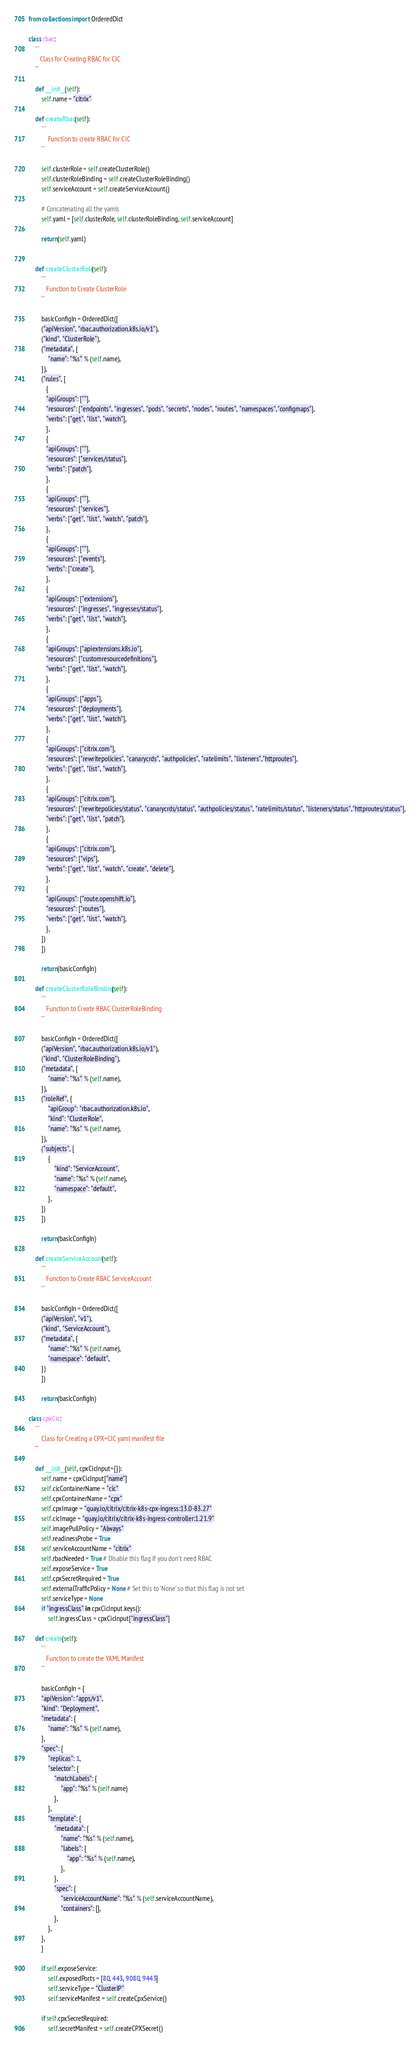Convert code to text. <code><loc_0><loc_0><loc_500><loc_500><_Python_>from collections import OrderedDict

class rbac:
    '''
       Class for Creating RBAC for CIC
    '''

    def __init__(self):
        self.name = "citrix"

    def createRbac(self):
        '''
            Function to create RBAC for CIC
        '''

        self.clusterRole = self.createClusterRole()
        self.clusterRoleBinding = self.createClusterRoleBinding()
        self.serviceAccount = self.createServiceAccount()

        # Concatenating all the yamls
        self.yaml = [self.clusterRole, self.clusterRoleBinding, self.serviceAccount]

        return(self.yaml)


    def createClusterRole(self):
        '''
           Function to Create ClusterRole
        '''

        basicConfigIn = OrderedDict([
        ("apiVersion", "rbac.authorization.k8s.io/v1"),
        ("kind", "ClusterRole"),
        ("metadata", {
            "name": "%s" % (self.name),
        }),
        ("rules", [
           {
           "apiGroups": [""],
           "resources": ["endpoints", "ingresses", "pods", "secrets", "nodes", "routes", "namespaces","configmaps"],
           "verbs": ["get", "list", "watch"],
           },
           {
           "apiGroups": [""],
           "resources": ["services/status"],
           "verbs": ["patch"],
           },
           {
           "apiGroups": [""],
           "resources": ["services"],
           "verbs": ["get", "list", "watch", "patch"],
           },
           {
           "apiGroups": [""],
           "resources": ["events"],
           "verbs": ["create"],
           },
           {
           "apiGroups": ["extensions"],
           "resources": ["ingresses", "ingresses/status"],
           "verbs": ["get", "list", "watch"],
           },
           {
           "apiGroups": ["apiextensions.k8s.io"],
           "resources": ["customresourcedefinitions"],
           "verbs": ["get", "list", "watch"],
           },
           {
           "apiGroups": ["apps"],
           "resources": ["deployments"],
           "verbs": ["get", "list", "watch"],
           },
           {
           "apiGroups": ["citrix.com"],
           "resources": ["rewritepolicies", "canarycrds", "authpolicies", "ratelimits", "listeners","httproutes"],
           "verbs": ["get", "list", "watch"],
           },
           {
           "apiGroups": ["citrix.com"],
           "resources": ["rewritepolicies/status", "canarycrds/status", "authpolicies/status", "ratelimits/status", "listeners/status","httproutes/status"],
           "verbs": ["get", "list", "patch"],
           },
           {
           "apiGroups": ["citrix.com"],
           "resources": ["vips"],
           "verbs": ["get", "list", "watch", "create", "delete"],
           },
           {
           "apiGroups": ["route.openshift.io"],
           "resources": ["routes"],
           "verbs": ["get", "list", "watch"],
           },
        ])
        ])

        return(basicConfigIn)

    def createClusterRoleBinding(self):
        '''
           Function to Create RBAC ClusterRoleBinding
        '''

        basicConfigIn = OrderedDict([
        ("apiVersion", "rbac.authorization.k8s.io/v1"),
        ("kind", "ClusterRoleBinding"),
        ("metadata", {
            "name": "%s" % (self.name),
        }),
        ("roleRef", {
            "apiGroup": "rbac.authorization.k8s.io",
            "kind": "ClusterRole",
            "name": "%s" % (self.name),
        }),
        ("subjects", [
            {
                "kind": "ServiceAccount",
                "name": "%s" % (self.name),
                "namespace": "default",
            },
        ])
        ])

        return(basicConfigIn)

    def createServiceAccount(self):
        '''
           Function to Create RBAC ServiceAccount
        '''

        basicConfigIn = OrderedDict([
        ("apiVersion", "v1"),
        ("kind", "ServiceAccount"),
        ("metadata", {
            "name": "%s" % (self.name),
            "namespace": "default",
        })
        ]) 

        return(basicConfigIn)

class cpxCic:
    '''
        Class for Creating a CPX+CIC yaml manifest file
    '''

    def __init__(self, cpxCicInput={}):
        self.name = cpxCicInput["name"]
        self.cicContainerName = "cic"
        self.cpxContainerName = "cpx"
        self.cpxImage = "quay.io/citrix/citrix-k8s-cpx-ingress:13.0-83.27"
        self.cicImage = "quay.io/citrix/citrix-k8s-ingress-controller:1.21.9"
        self.imagePullPolicy = "Always"
        self.readinessProbe = True
        self.serviceAccountName = "citrix"
        self.rbacNeeded = True # Disable this flag if you don't need RBAC
        self.exposeService = True
        self.cpxSecretRequired = True
        self.externalTrafficPolicy = None # Set this to 'None' so that this flag is not set
        self.serviceType = None
        if "ingressClass" in cpxCicInput.keys():
            self.ingressClass = cpxCicInput["ingressClass"]

    def create(self):
        '''
           Function to create the YAML Manifest
        '''

        basicConfigIn = {
        "apiVersion": "apps/v1",
        "kind": "Deployment",
        "metadata": {
            "name": "%s" % (self.name),
        },
        "spec": {
            "replicas": 1,
            "selector": {
                "matchLabels": {
                    "app": "%s" % (self.name)
                },
            },
            "template": {
                "metadata": {
                    "name": "%s" % (self.name),
                    "labels": {
                        "app": "%s" % (self.name),
                    },
                },
                "spec": {
                    "serviceAccountName": "%s" % (self.serviceAccountName),
                    "containers": [],
                },
            },
        },
        }

        if self.exposeService:
            self.exposedPorts = [80, 443, 9080, 9443]
            self.serviceType = "ClusterIP"
            self.serviceManifest = self.createCpxService()

        if self.cpxSecretRequired:
            self.secretManifest = self.createCPXSecret()
</code> 